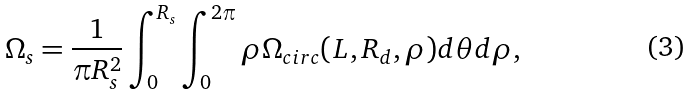<formula> <loc_0><loc_0><loc_500><loc_500>\Omega _ { s } = \frac { 1 } { \pi R _ { s } ^ { 2 } } \int _ { 0 } ^ { R _ { s } } \int _ { 0 } ^ { 2 \pi } \rho \Omega _ { c i r c } ( L , R _ { d } , \rho ) d \theta d \rho ,</formula> 